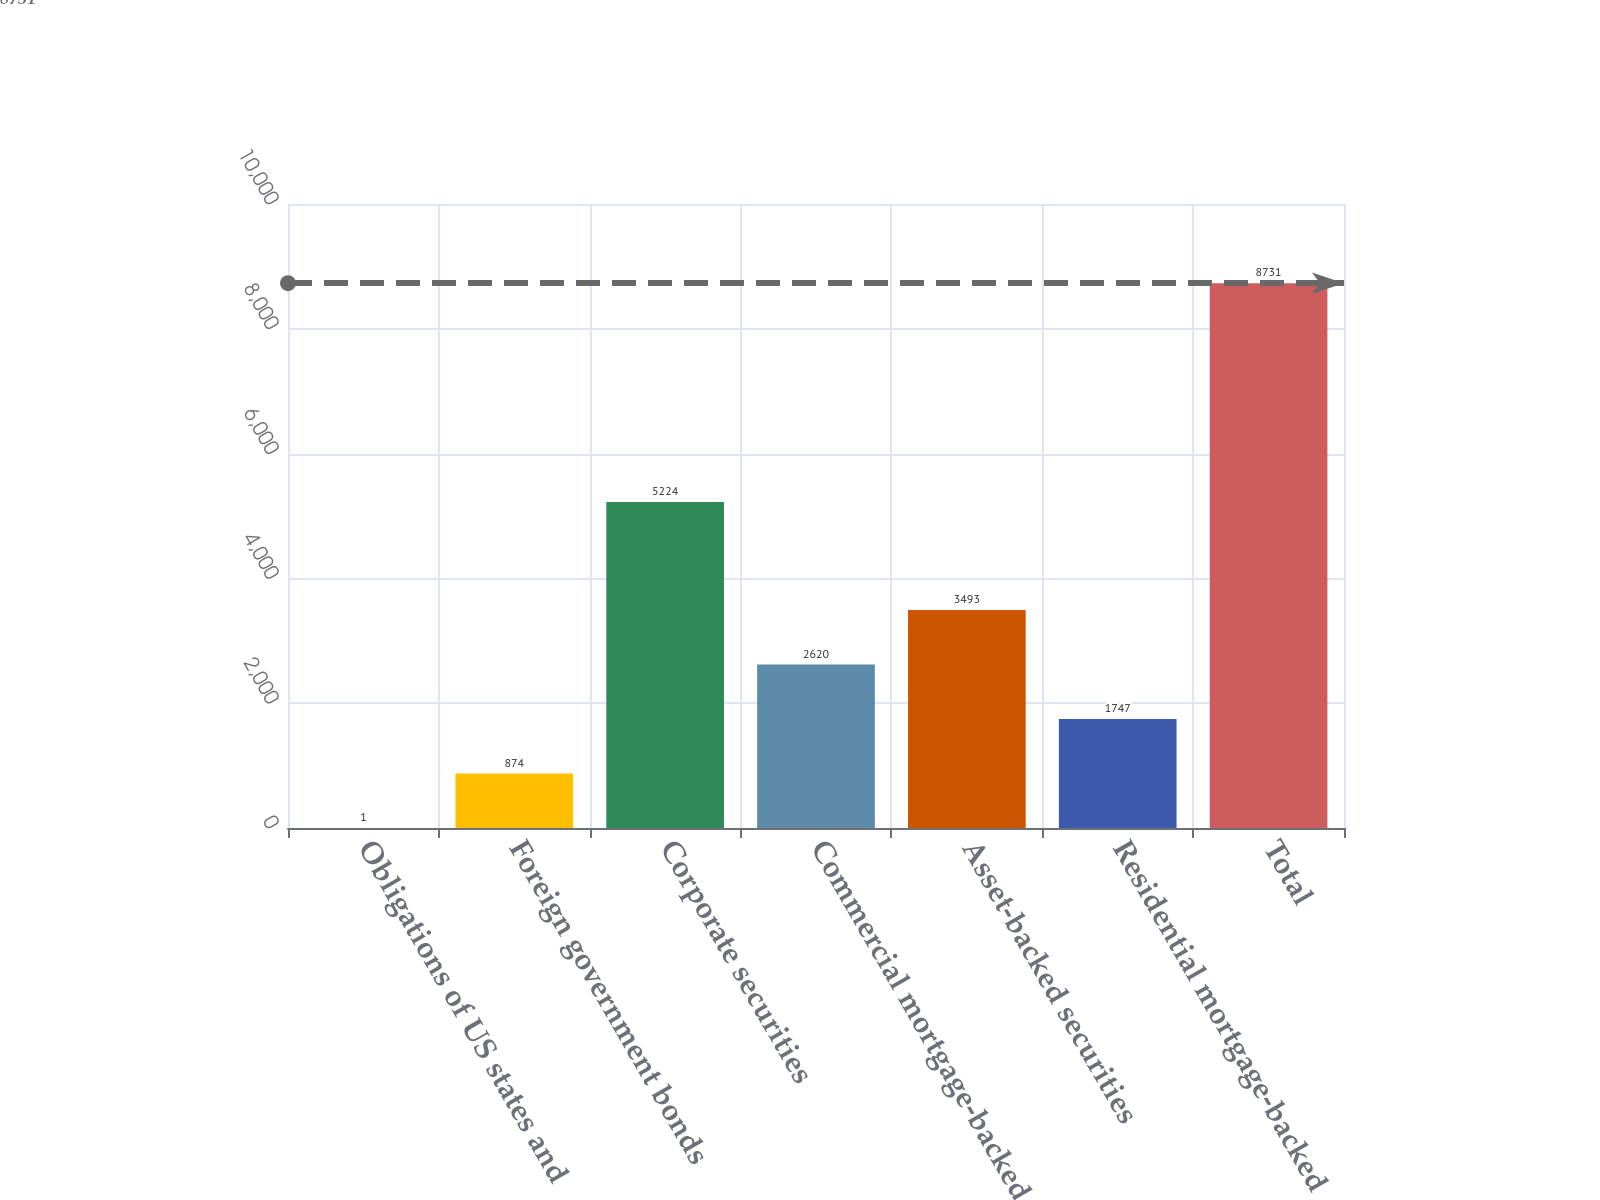<chart> <loc_0><loc_0><loc_500><loc_500><bar_chart><fcel>Obligations of US states and<fcel>Foreign government bonds<fcel>Corporate securities<fcel>Commercial mortgage-backed<fcel>Asset-backed securities<fcel>Residential mortgage-backed<fcel>Total<nl><fcel>1<fcel>874<fcel>5224<fcel>2620<fcel>3493<fcel>1747<fcel>8731<nl></chart> 